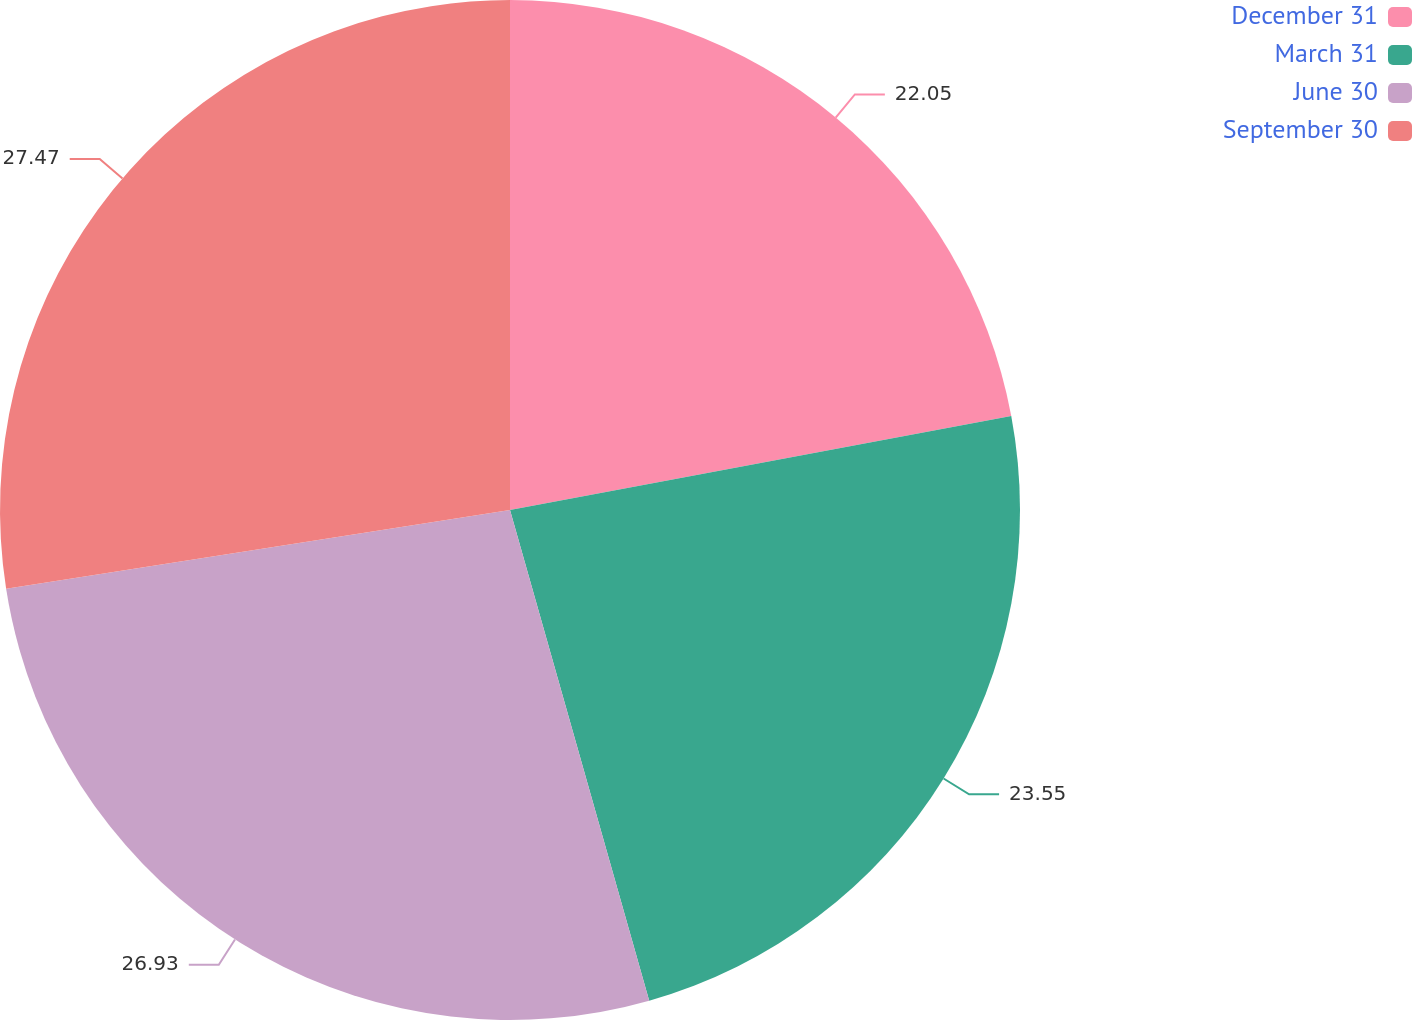Convert chart to OTSL. <chart><loc_0><loc_0><loc_500><loc_500><pie_chart><fcel>December 31<fcel>March 31<fcel>June 30<fcel>September 30<nl><fcel>22.05%<fcel>23.55%<fcel>26.93%<fcel>27.47%<nl></chart> 